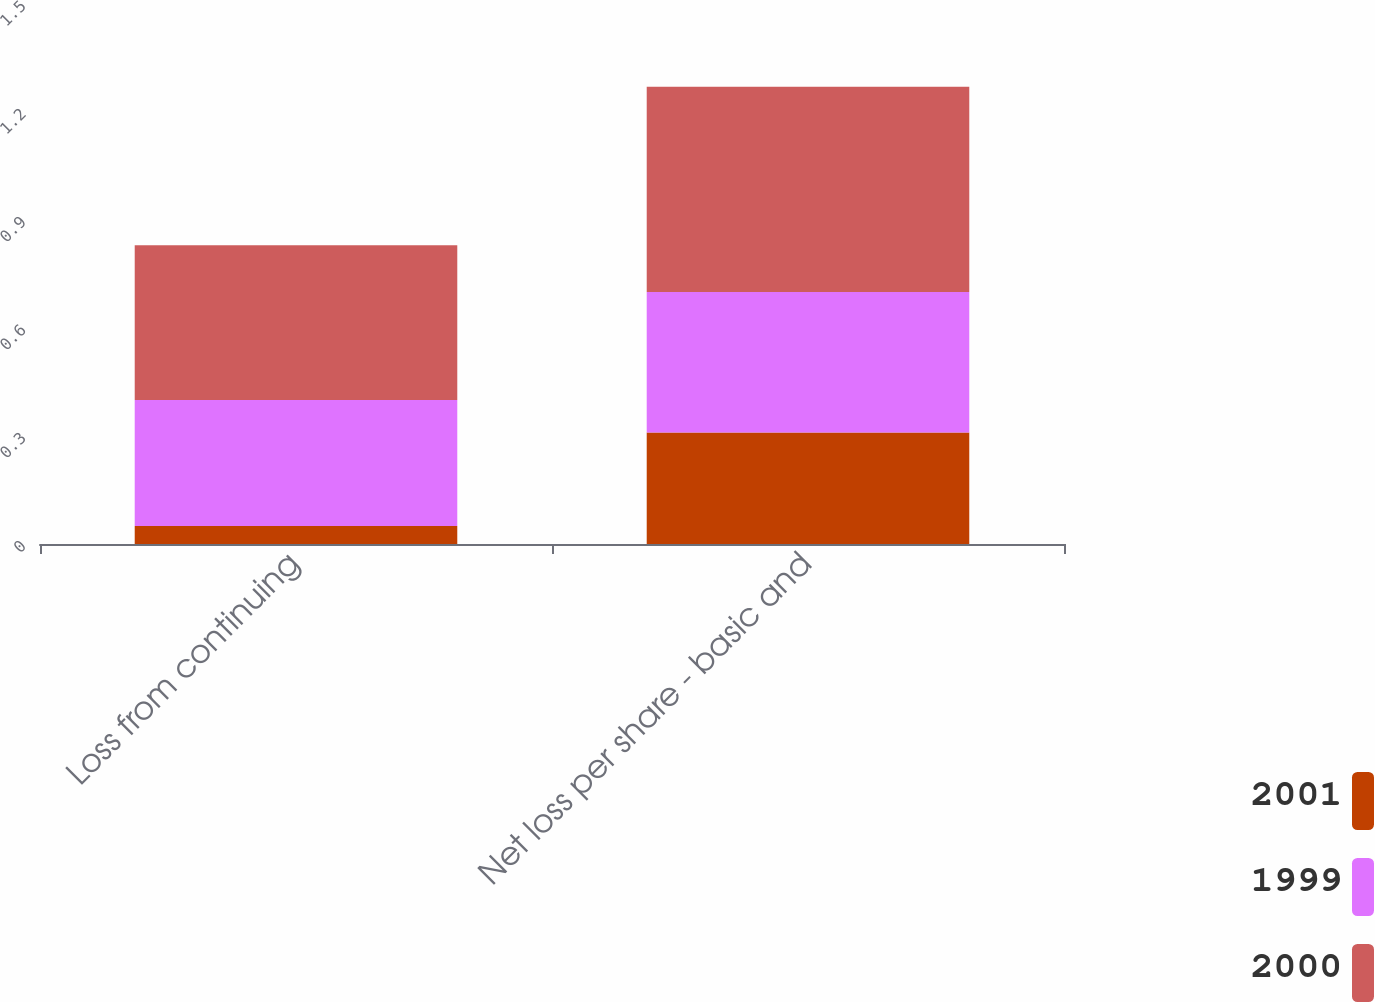Convert chart. <chart><loc_0><loc_0><loc_500><loc_500><stacked_bar_chart><ecel><fcel>Loss from continuing<fcel>Net loss per share - basic and<nl><fcel>2001<fcel>0.05<fcel>0.31<nl><fcel>1999<fcel>0.35<fcel>0.39<nl><fcel>2000<fcel>0.43<fcel>0.57<nl></chart> 